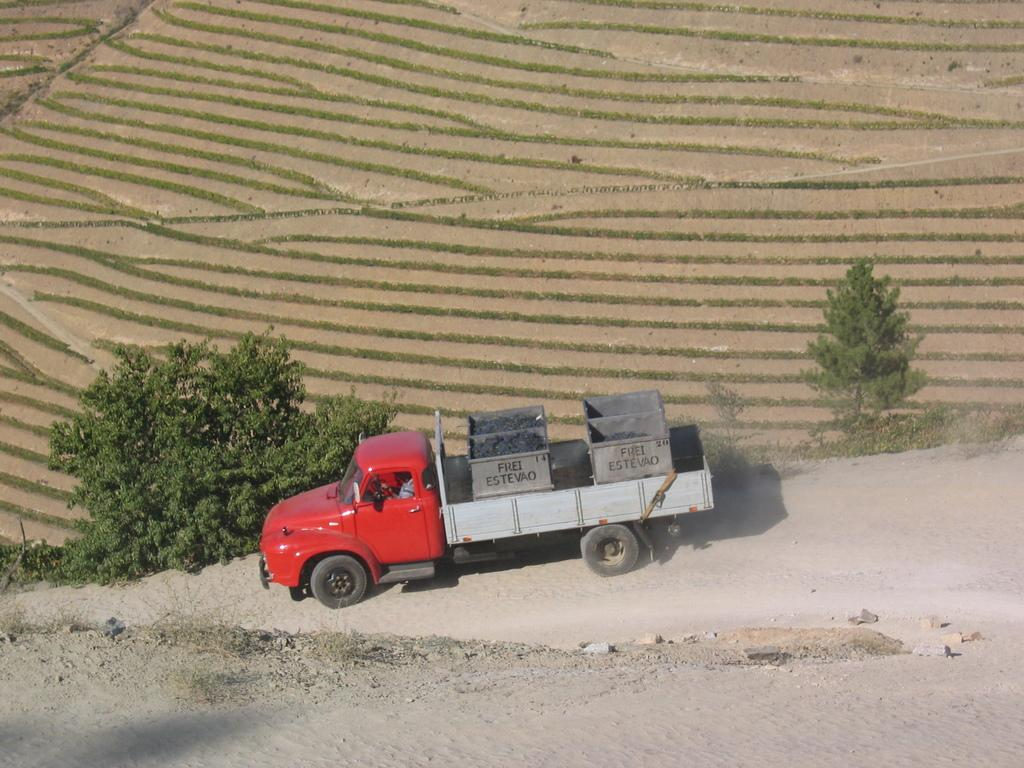What type of landscape is depicted in the image? The image shows agricultural land. Are there any specific features in the landscape? Yes, there are two trees in the image. What is the vehicle in the image used for? There is a small truck in the image, and it is likely used for transportation or work purposes. Who is operating the truck in the image? A person is driving the truck in the image. What type of alarm can be heard going off in the image? There is no alarm present in the image, and therefore no such sound can be heard. 